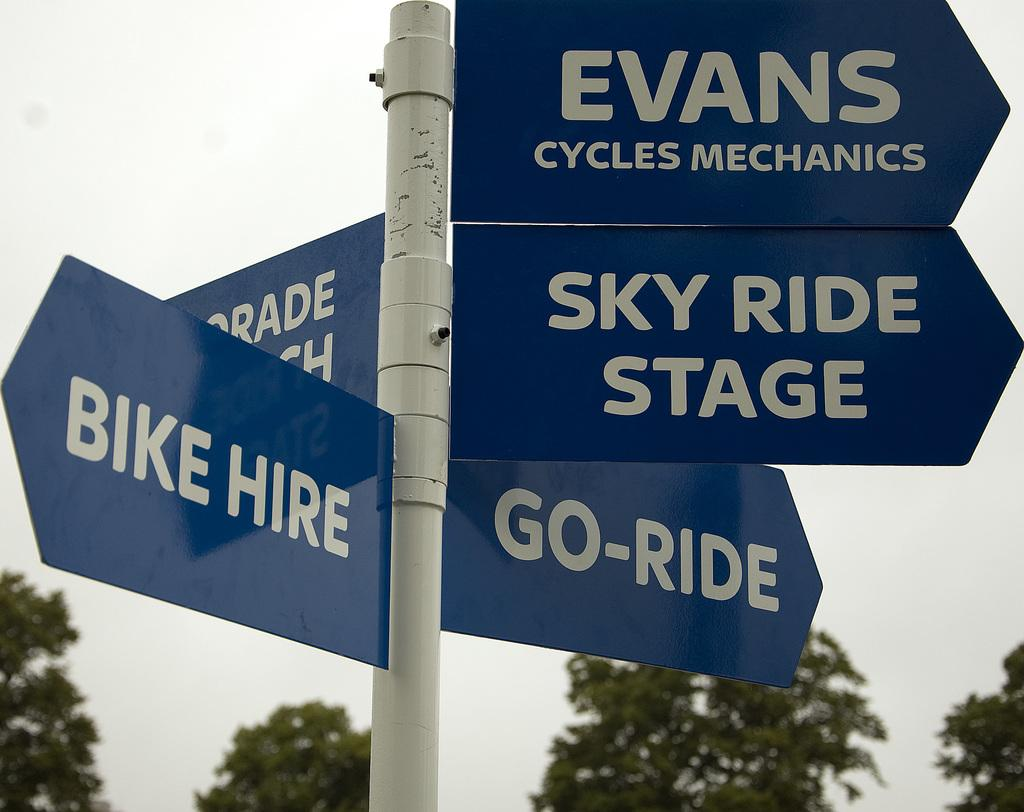What is the main object in the image? There is a pole in the image. What is attached to the pole? Many sign boards are attached to the pole. What can be seen in the background of the image? There are trees and the sky visible in the background of the image. Can you see any friends gathering at the cemetery in the image? There is no cemetery or friends present in the image. Is there any magic happening around the pole in the image? There is no magic or any indication of supernatural activity in the image. 